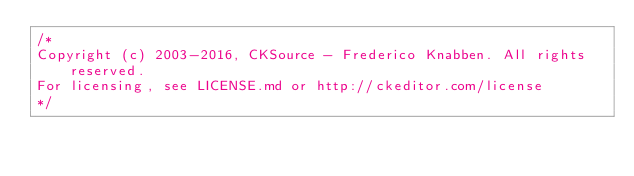Convert code to text. <code><loc_0><loc_0><loc_500><loc_500><_JavaScript_>/*
Copyright (c) 2003-2016, CKSource - Frederico Knabben. All rights reserved.
For licensing, see LICENSE.md or http://ckeditor.com/license
*/</code> 